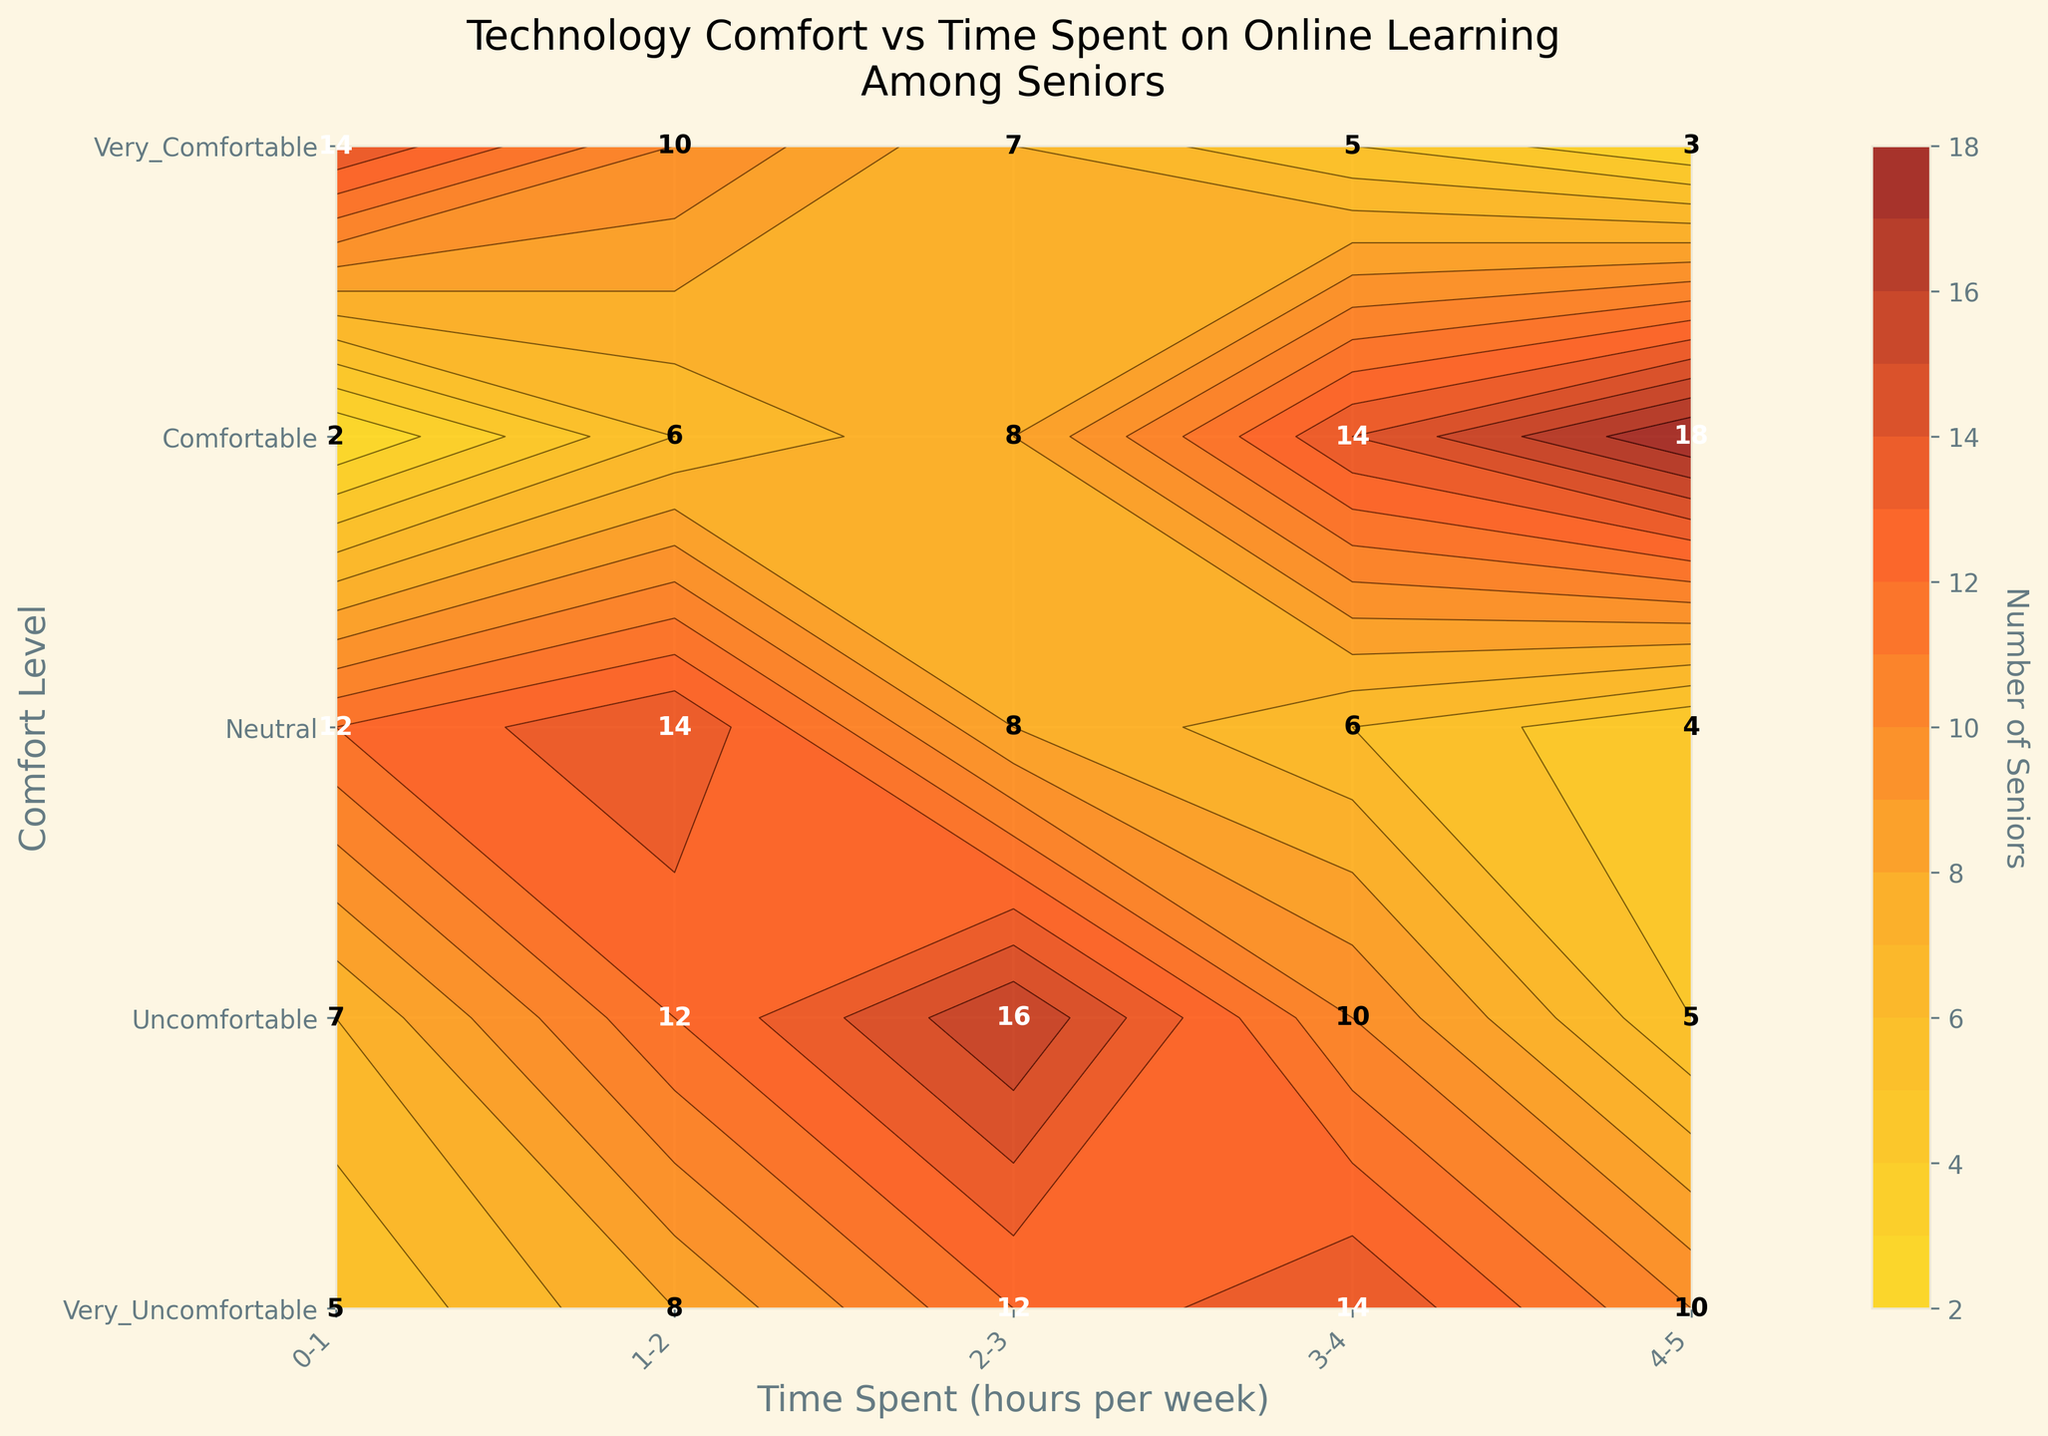What is the title of the plot? The title is clearly indicated at the top of the plot ("Technology Comfort vs Time Spent on Online Learning\nAmong Seniors").
Answer: Technology Comfort vs Time Spent on Online Learning Among Seniors What is the color of regions with the highest number of seniors? The highest number of seniors is represented by the darkest color on the plot, which is a deep red.
Answer: Deep red Which comfort level has the greatest number of seniors spending 4-5 hours per week online? Look at the labels on the Y-axis and the contour labels or color gradient at 4-5 hours on the X-axis. "Very Comfortable" shows the highest number, represented by the darkest contour color.
Answer: Very Comfortable How many seniors feel "Neutral" and spend 2-3 hours per week online? Locate the "Neutral" row on the Y-axis, then the "2-3" column on the X-axis. Look at the number inside this grid cell.
Answer: 16 Compare the number of seniors who are "Very Uncomfortable" versus "Comfortable" at 1-2 hours per week. Which is higher, and by how much? Look at the "Very Uncomfortable" row for 1-2 hours (10) and the "Comfortable" row for 1-2 hours (8). Subtract to find the difference.
Answer: Very Uncomfortable by 2 What range of time spent has the highest variability in the number of seniors across all comfort levels? Examine the range along the X-axis with the most significant difference in the number of seniors between the highest and lowest contours.
Answer: 3-4 hours What is the summed total of seniors who spend 0-1 hours per week online across all comfort levels? Add up the numbers in the entire first column of the grid (14+12+7+5+2).
Answer: 40 For the "Uncomfortable" seniors, which time spent category has the smallest number? Check the row labeled "Uncomfortable" and identify the smallest number in this row.
Answer: 4 (for 4-5 hours per week) Is there a trend shown in the plot where seniors who spend more time online feel more comfortable with technology? By observing the figure, as time spent increases (left to right on the X-axis), the number of seniors in the more comfortable categories (bottom to top on the Y-axis) generally increases.
Answer: Yes Which comfort level has the highest total number of seniors across all time spent categories? Sum the numbers in each row and identify the row with the highest sum.
Answer: Very Comfortable 